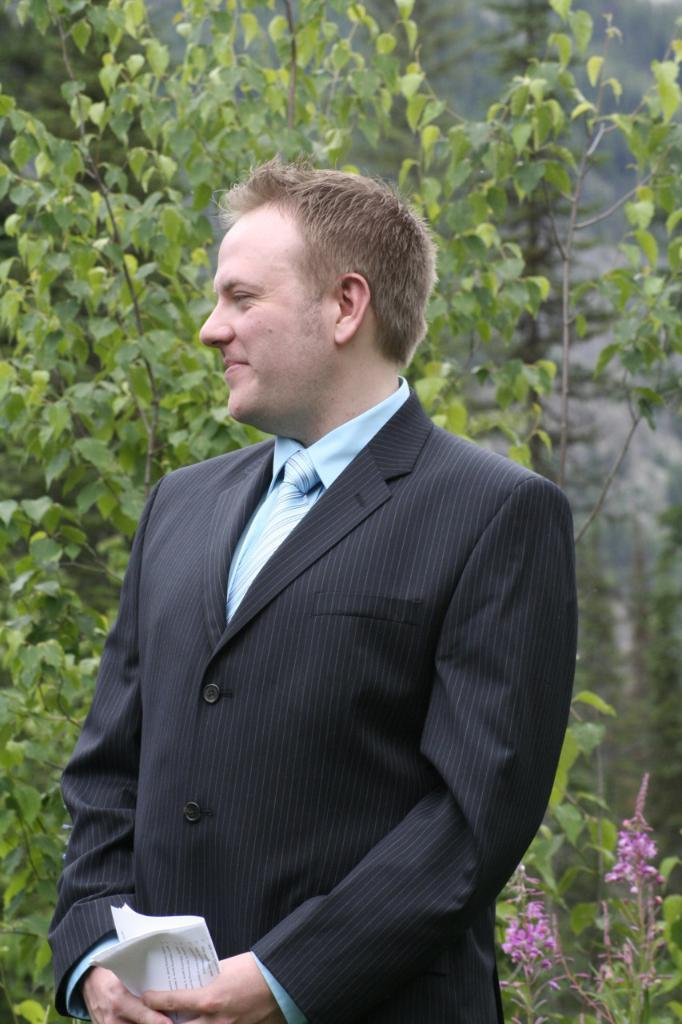What is the main subject of the image? There is a person in the image. What is the person wearing? The person is wearing a black coat and a blue tie. What is the person holding in the image? The person is holding papers. What can be seen in the background of the image? There are trees and pink flowers visible in the background. What type of hydrant is visible in the image? There is no hydrant present in the image. What instruments is the band playing in the background of the image? There is no band present in the image. 